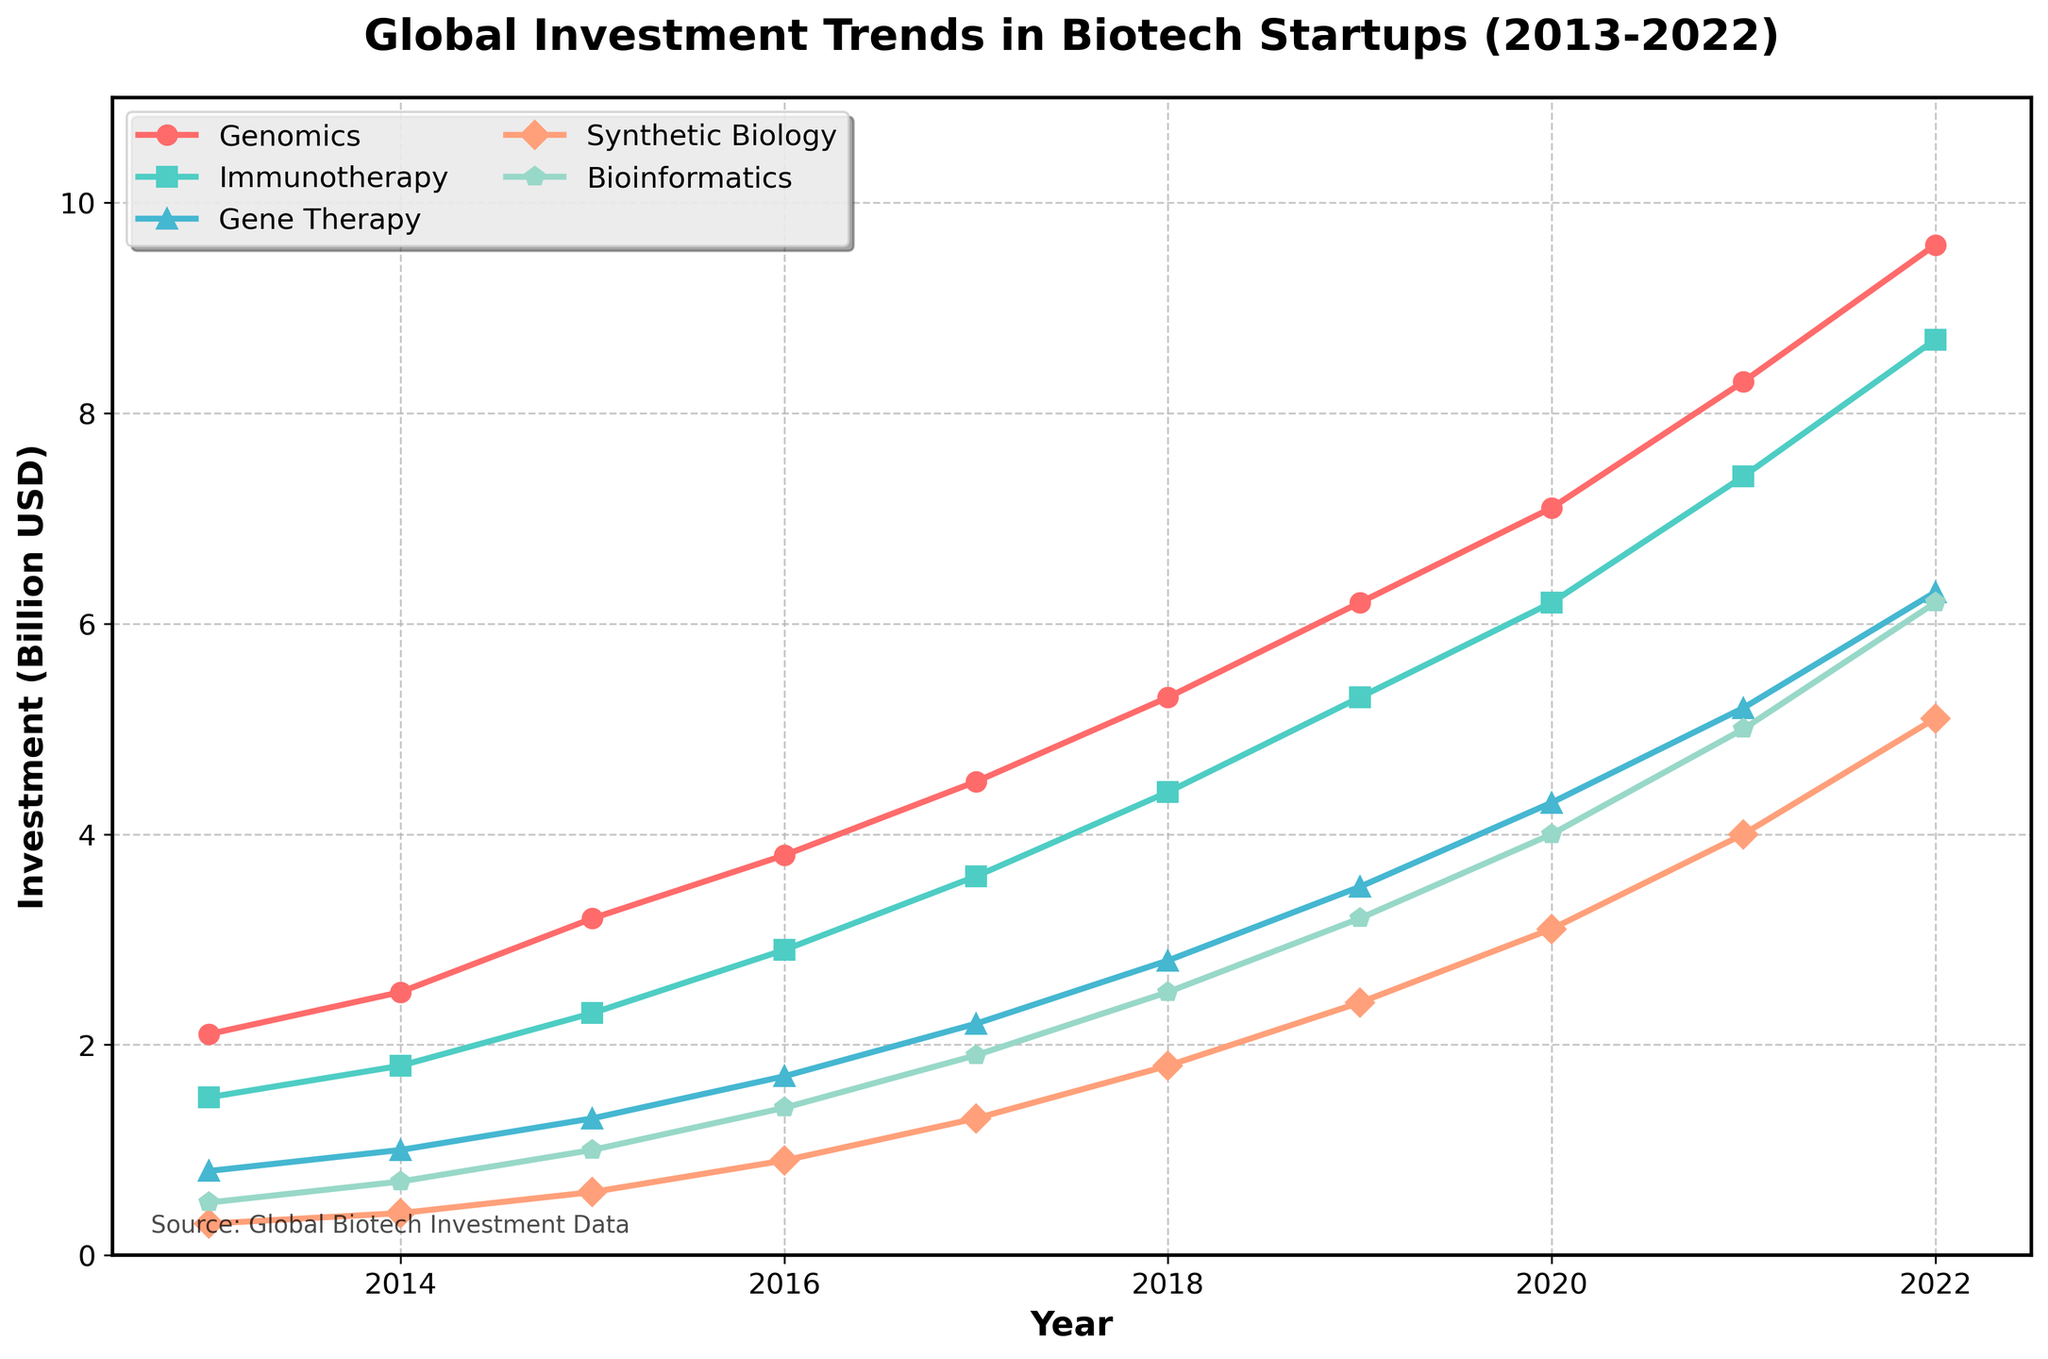what is the largest investment sector in 2022? Observe the endpoint of each line in the chart for the year 2022. The line representing "Genomics" reaches the highest point compared to other sectors.
Answer: Genomics Which year saw the largest increase in Bioinformatics investment? Find the steepest upward slope of the line representing Bioinformatics. The segment from 2020 to 2021 shows the largest increase.
Answer: 2021 What was the difference between investments in Immunotherapy and Gene Therapy in 2017? Locate the 2017 values from the chart for both Immunotherapy and Gene Therapy. Subtract the investment in Gene Therapy from the investment in Immunotherapy (3.6 - 2.2).
Answer: 1.4 What is the average investment in Synthetic Biology across all years? Sum the investment values for Synthetic Biology across all years, then divide by the number of years (0.3 + 0.4 + 0.6 + 0.9 + 1.3 + 1.8 + 2.4 + 3.1 + 4.0 + 5.1) / 10.
Answer: 2.39 During which year did Genomics investments surpass 6 billion USD? Identify the point where the Genomics line crosses the 6 billion USD mark. It happens between 2019 and 2020.
Answer: 2020 How many sectors had investments above 4 billion USD in 2022? Count the sectors whose endpoints for the year 2022 are above the 4 billion USD mark. Genomics, Immunotherapy, Gene Therapy, and Bioinformatics meet this criterion.
Answer: 4 Compare the investment trends of Genomics and Synthetic Biology. Which one had a more significant growth rate? Examine the slope of both Genomics and Synthetic Biology lines from 2013 to 2022. Genomics has a steeper slope, indicating a more significant growth rate.
Answer: Genomics What is the total investment in Gene Therapy from 2013 to 2015? Sum the investment values of Gene Therapy from 2013, 2014, and 2015 (0.8 + 1.0 + 1.3).
Answer: 3.1 